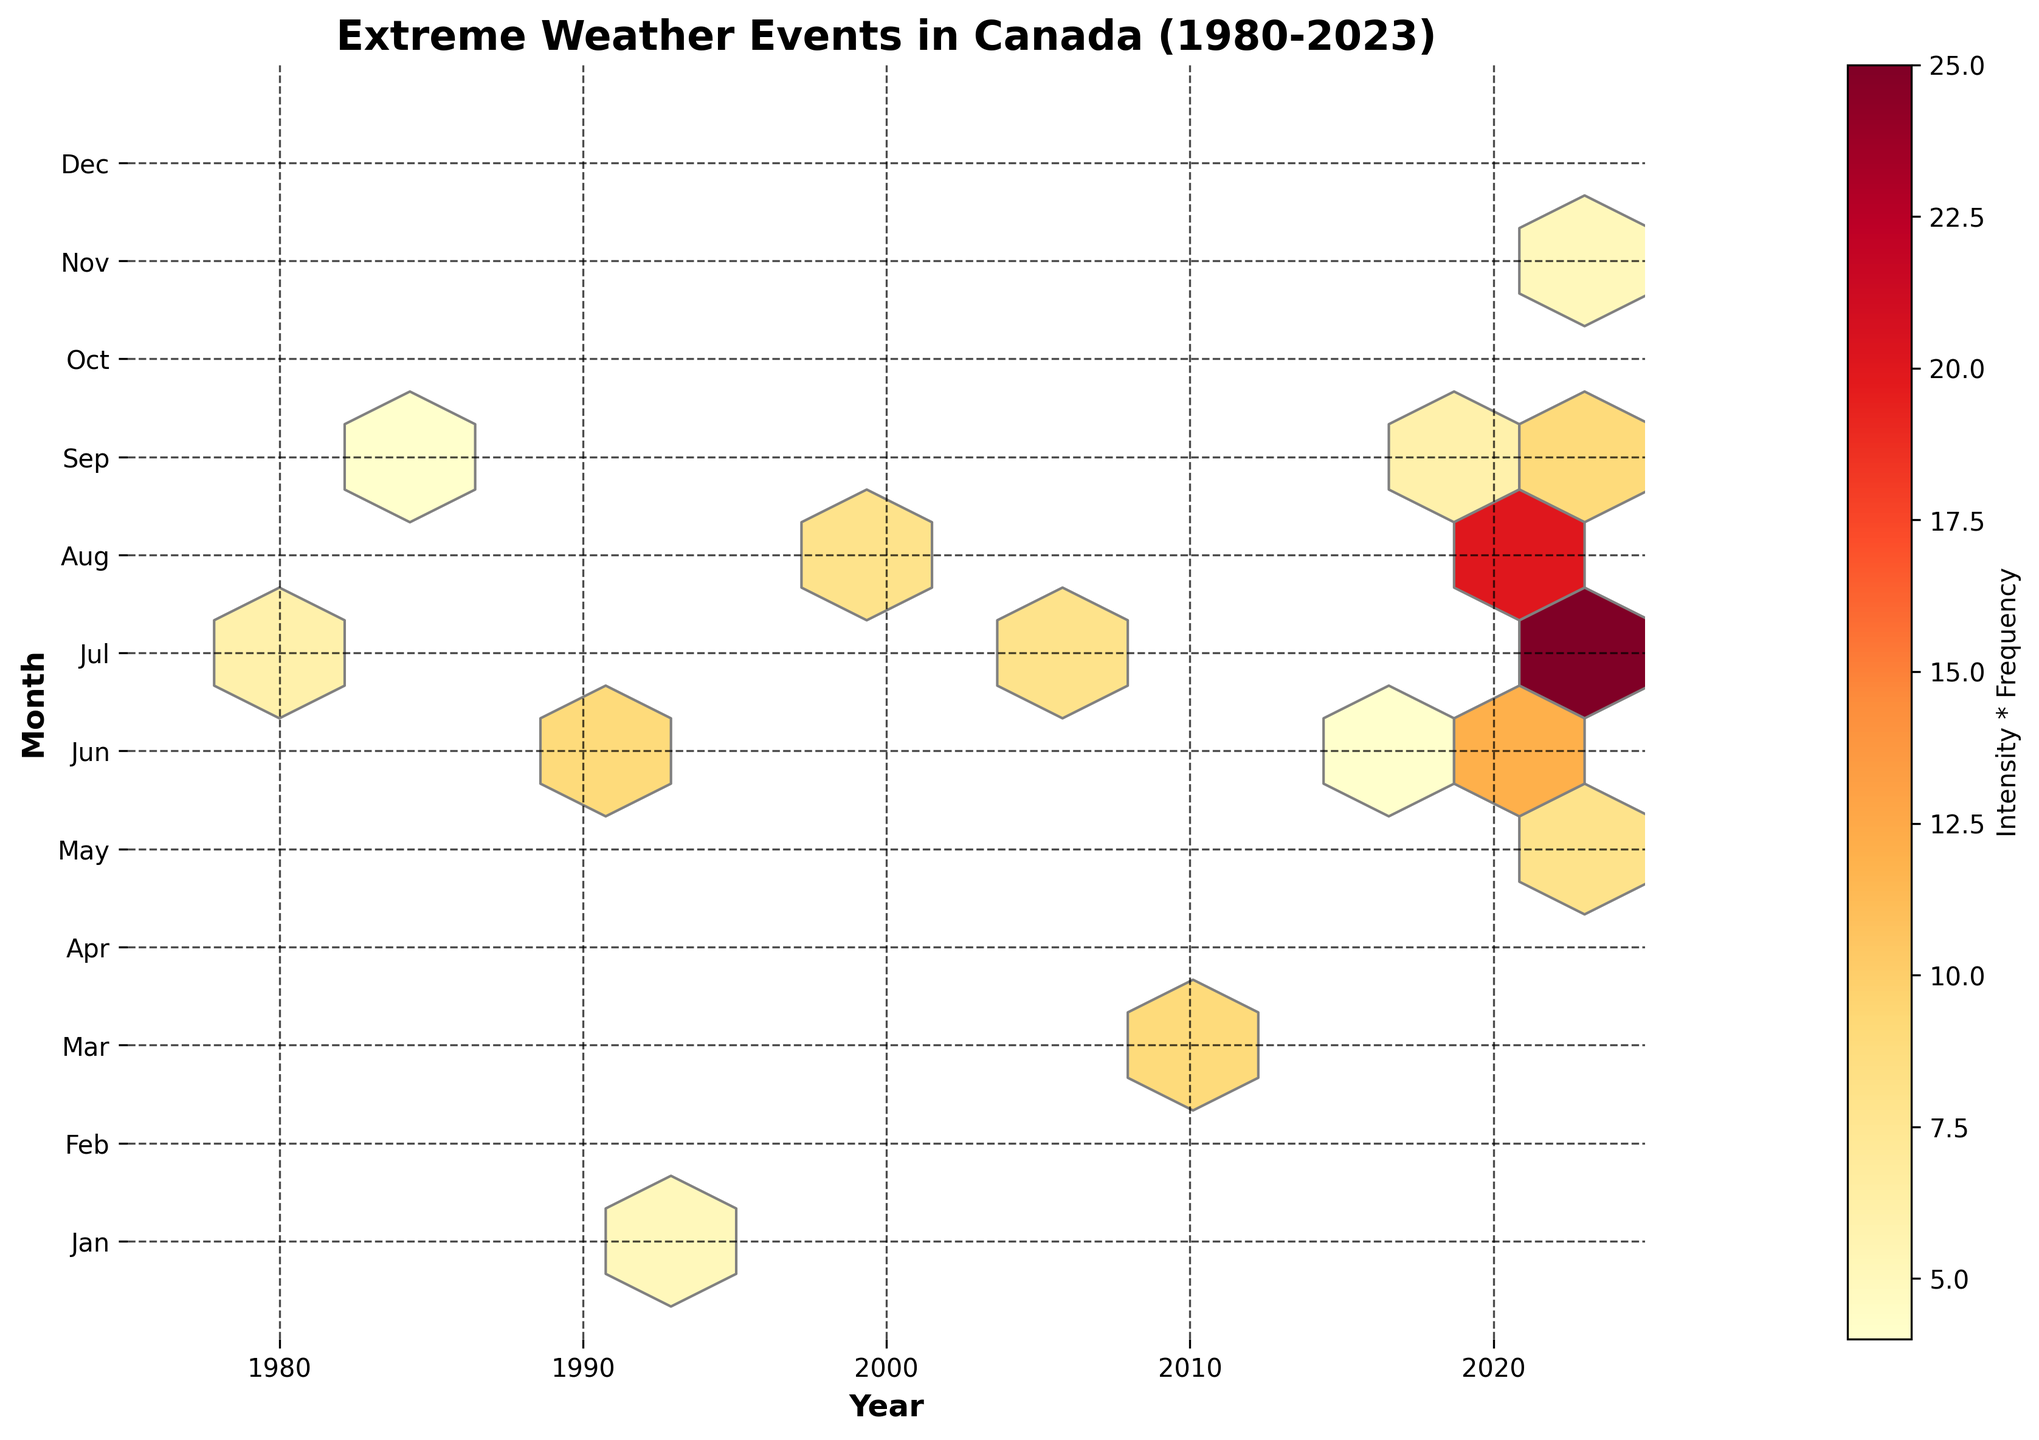What's the title of the figure? The title is the text provided at the top of the plot. According to the code, it is set using `ax.set_title`.
Answer: Extreme Weather Events in Canada (1980-2023) What do the axes represent in the figure? The labels on the axes indicate what each axis represents. The x-axis label is 'Year' and the y-axis label is 'Month', as set by the `ax.set_xlabel` and `ax.set_ylabel` methods.
Answer: Year and Month What does the color bar represent in the plot? The color bar label is set by `fig.colorbar`, indicating 'Intensity * Frequency'. The color variations show different values of this product.
Answer: Intensity * Frequency Which year and month had the highest concentration of extreme weather events? Look for the hexbin cell with the highest color intensity in the plot. This corresponds to the highest value of `Intensity * Frequency`. The code snippet does not list specific values, but you can visually identify it from the highest color intensity.
Answer: The highest color intensity observed What is the overall trend in the frequency and intensity of extreme weather events over the years? Looking at the x-axis, observe if the color intensities and concentrations of events increase, decrease, or stay constant over time. Notice where the densest clusters appear along the years.
Answer: Increasing (if densest clusters appear towards recent years) Which month consistently experiences high-intensity extreme weather events? Observe along the y-axis for months with consistently higher color intensities. Higher colors pointing to higher `Intensity * Frequency`.
Answer: July (assuming July cells are consistently intense) What does the intensity * frequency value indicate in the context of this plot? Higher intensity * frequency value means either or both parameters are higher, indicating more severe or frequent events in specific months/years. The visual density and color define the severity and regularity.
Answer: Severity and regularity of events Do any specific months or years show a notable absence of extreme weather events? Look for areas along the axes with less color density or empty spaces, where hex cells are sparse or non-existent, indicating fewer or no recorded events.
Answer: Notable gaps along all but summer months Which event, in terms of combined intensity and frequency, changed the most over the years? Identify the hex cells with major intensity changes across the timeline (x-axis), and note the differences across similar months (y-axis) over various years.
Answer: Wildfire (if identified from hex bins showing varying intensities) How do the hexagonal bins help in understanding the data on extreme weather events? Hexagonal bins show density and distribution over time and months, allowing observation of clustering patterns that signify trends without cluttering the visualization.
Answer: Summarizes data density and patterns 